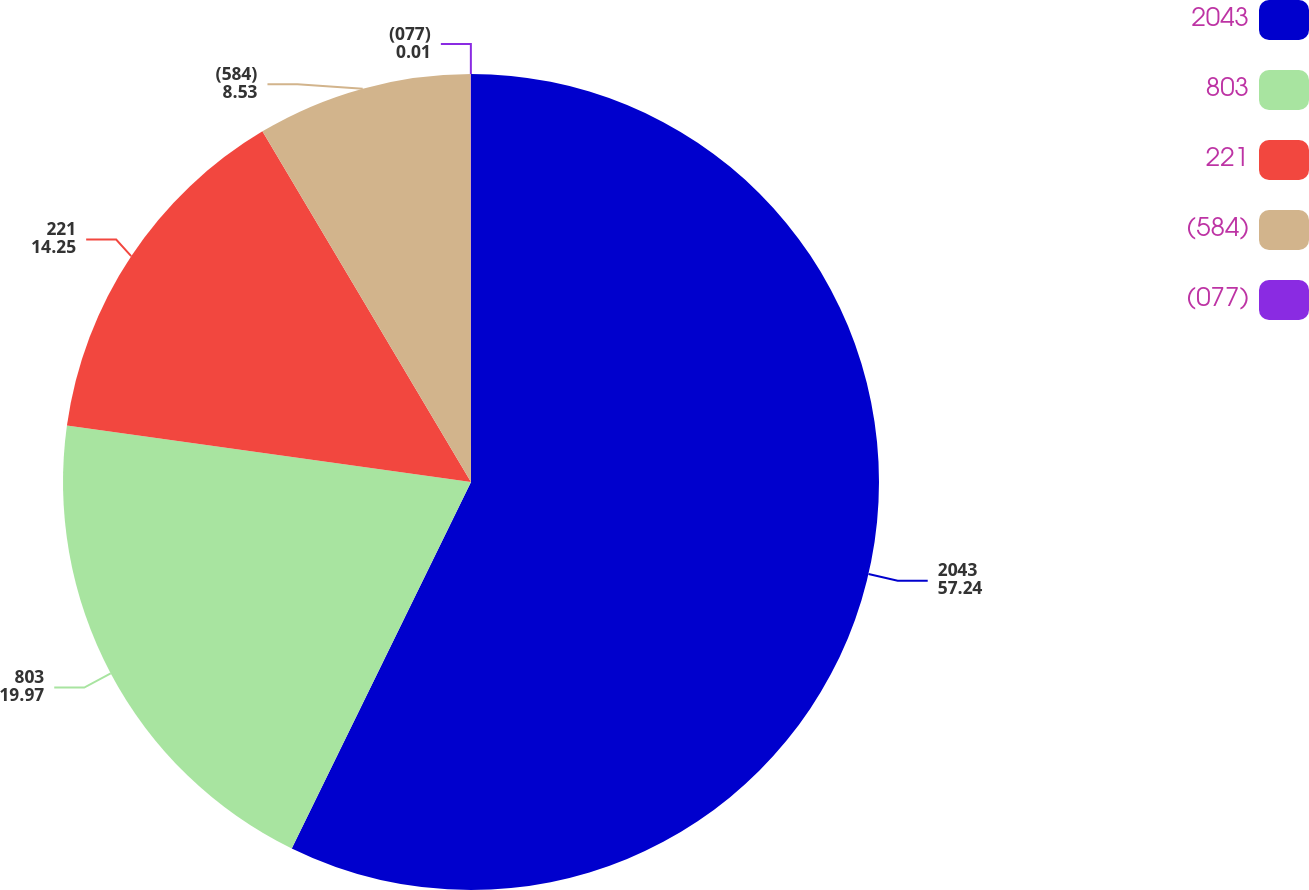Convert chart to OTSL. <chart><loc_0><loc_0><loc_500><loc_500><pie_chart><fcel>2043<fcel>803<fcel>221<fcel>(584)<fcel>(077)<nl><fcel>57.24%<fcel>19.97%<fcel>14.25%<fcel>8.53%<fcel>0.01%<nl></chart> 